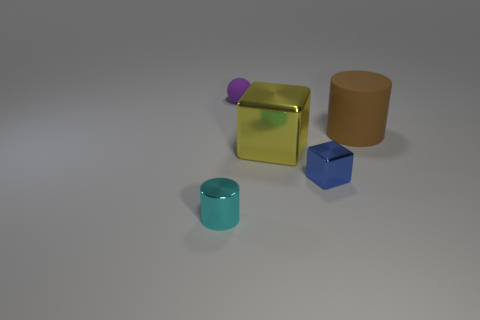In terms of lighting and shadows, how would you describe this scene? The lighting in this scene provides a soft, ambient effect with a gentle spread, suggesting an overcast sky or diffused artificial light source. All objects cast subtle shadows directly beneath them, with the shadows stretching slightly to the right, indicating that the light source is coming from the left-hand side of the frame. The softness of the shadows also contributes to the feeling of a diffuse light environment. Overall, the lighting and shadows create a calm and somewhat muted atmosphere. 